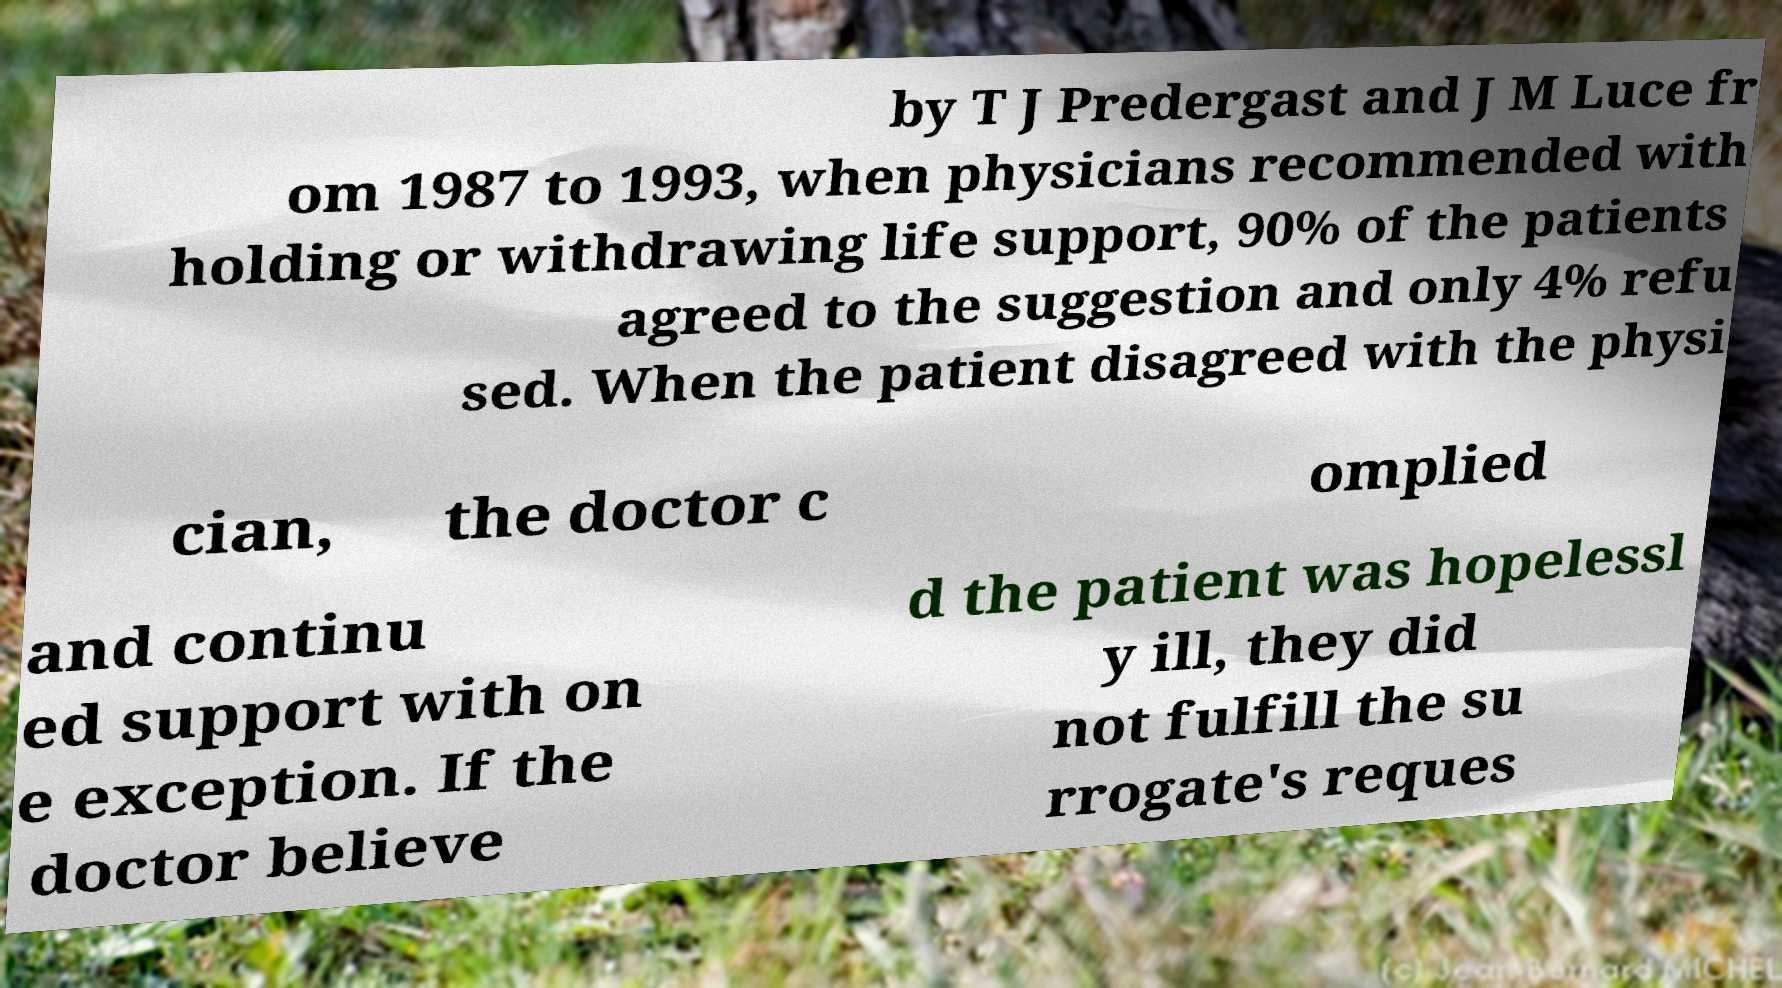Please read and relay the text visible in this image. What does it say? by T J Predergast and J M Luce fr om 1987 to 1993, when physicians recommended with holding or withdrawing life support, 90% of the patients agreed to the suggestion and only 4% refu sed. When the patient disagreed with the physi cian, the doctor c omplied and continu ed support with on e exception. If the doctor believe d the patient was hopelessl y ill, they did not fulfill the su rrogate's reques 